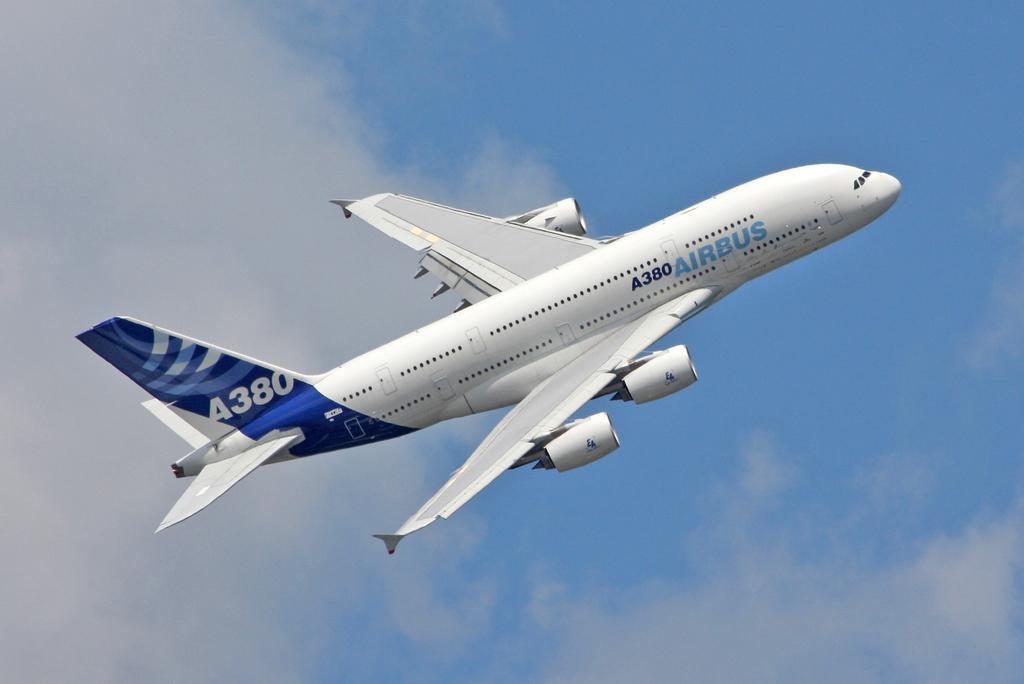Please provide a concise description of this image. In this picture, we see an airplane in white and blue color is flying in the sky. On the airplane, it is written as "AIRBUS". In the background, we see the clouds and the sky, which is blue in color. 